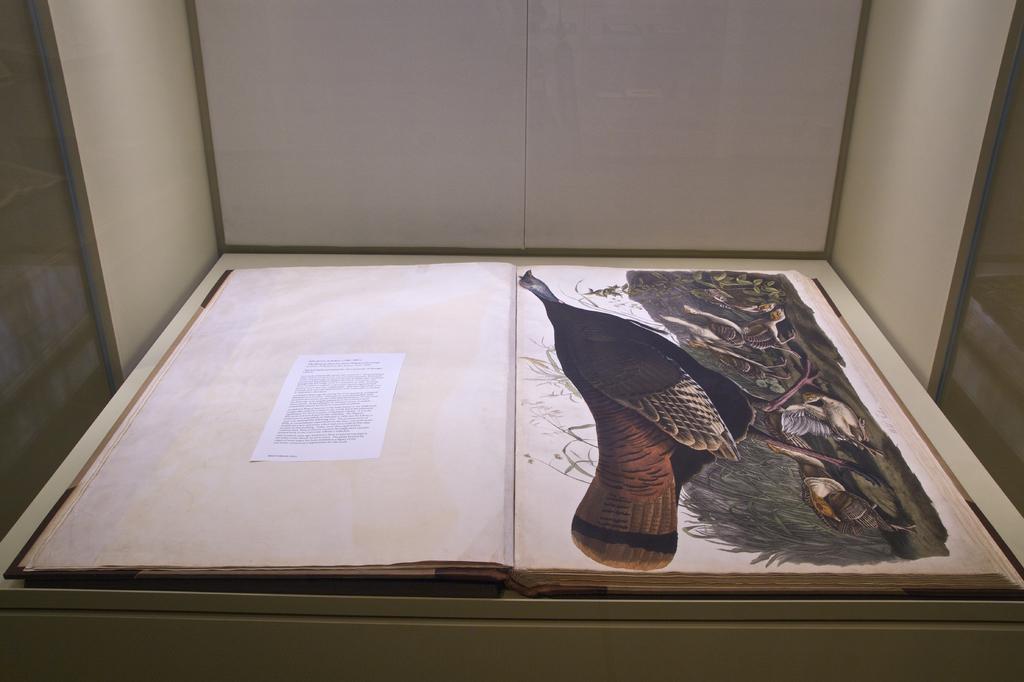In one or two sentences, can you explain what this image depicts? In the image there is an open book on the surface. Inside the book there are images of birds. And also there is a paper with text on it. On both left and right corners of the image there are glass walls. And there is a white background. 